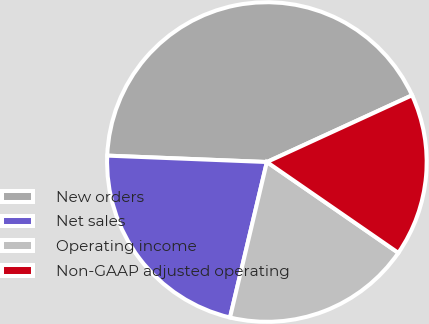Convert chart. <chart><loc_0><loc_0><loc_500><loc_500><pie_chart><fcel>New orders<fcel>Net sales<fcel>Operating income<fcel>Non-GAAP adjusted operating<nl><fcel>42.5%<fcel>21.93%<fcel>19.08%<fcel>16.48%<nl></chart> 